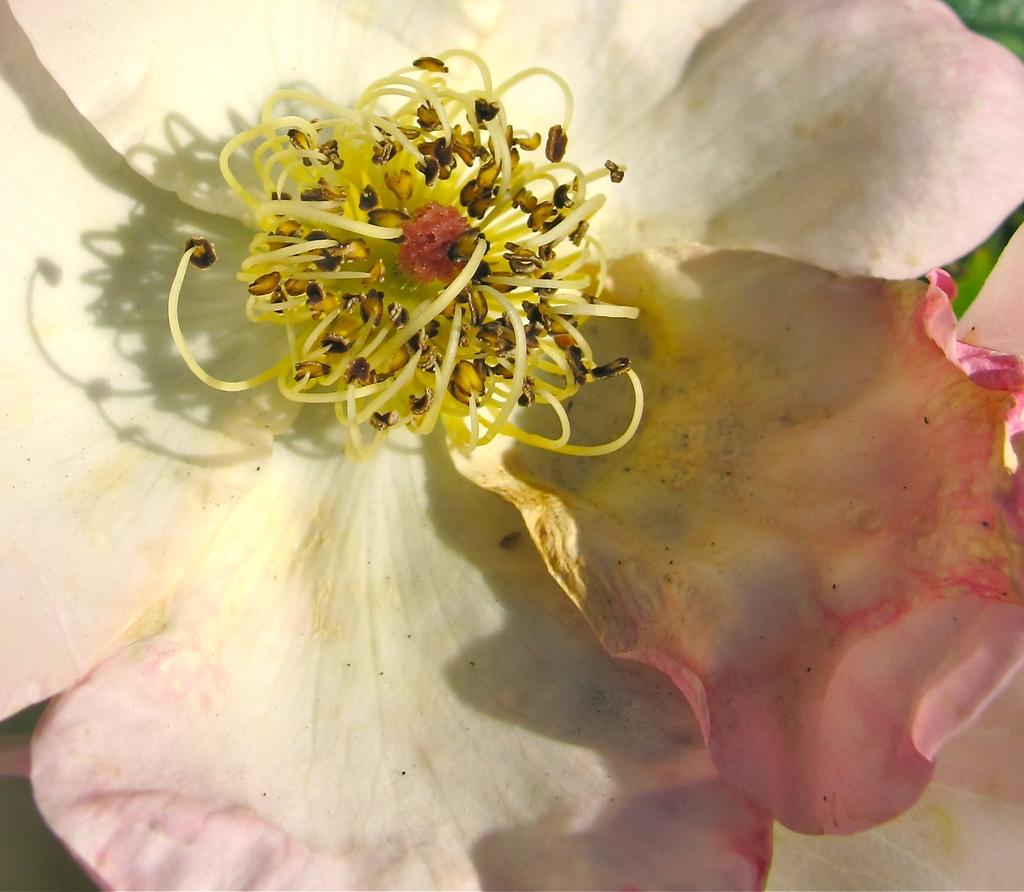What is the main subject of the image? The main subject of the image is a flower. Can you describe the colors of the flower? The flower has white and pink colors. How many eggs are present in the image? There are no eggs present in the image; it features a flower with white and pink colors. 